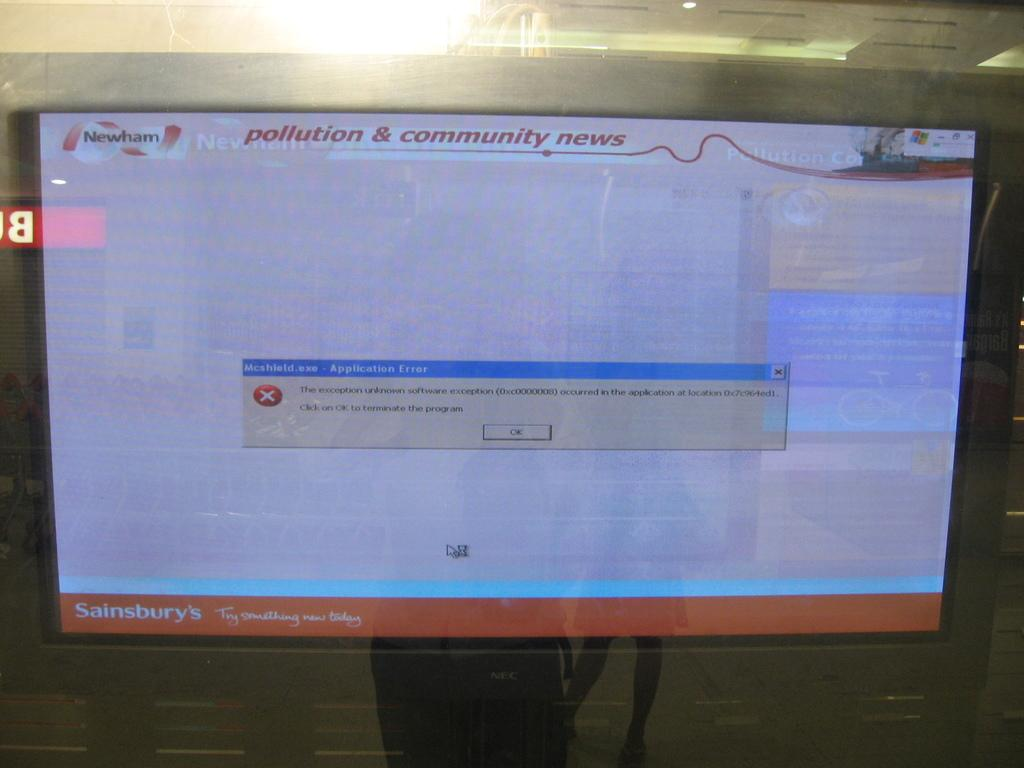Provide a one-sentence caption for the provided image. a computer screen with an error message on it, with the title 'pollution & community news'. 